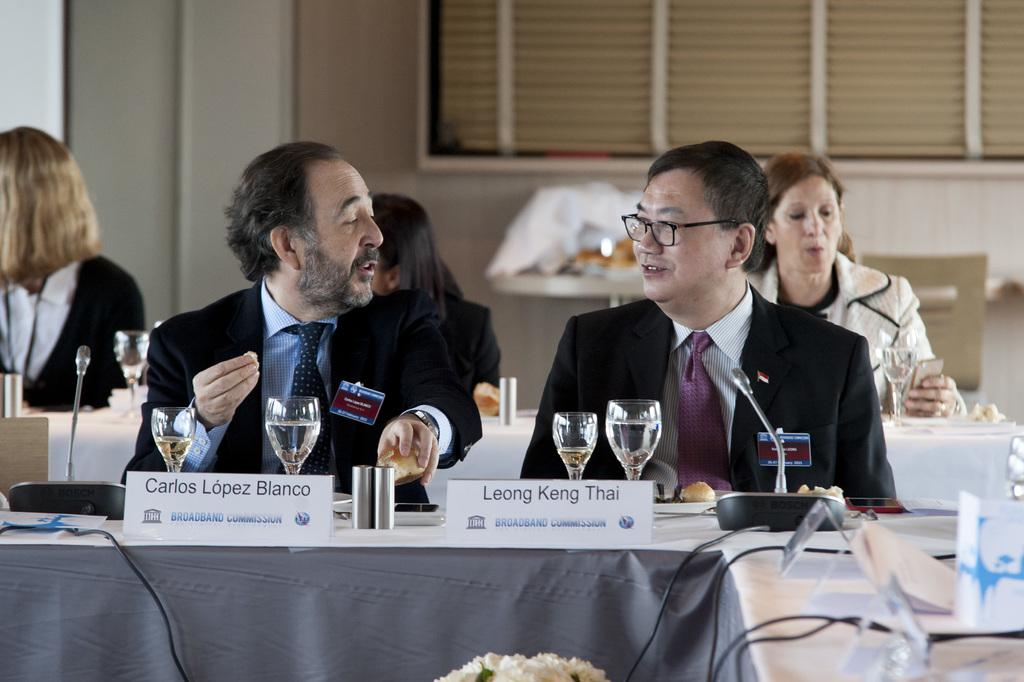Provide a one-sentence caption for the provided image. Leong Keng Thai is sitting at a table next to Carlos Lopez Bianco. 